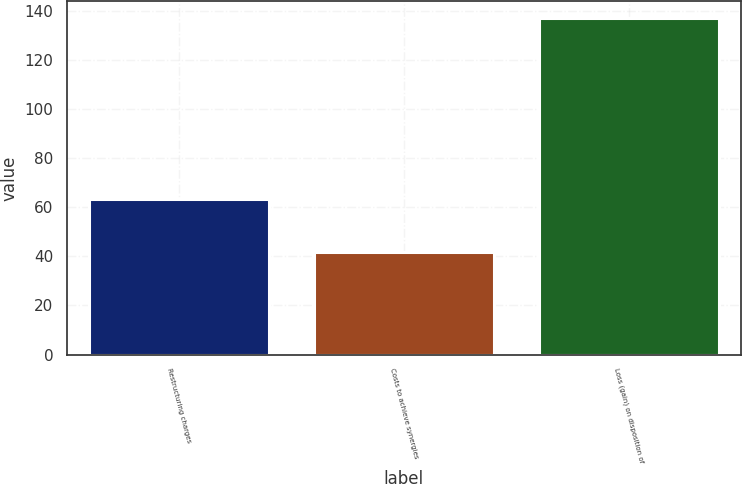Convert chart to OTSL. <chart><loc_0><loc_0><loc_500><loc_500><bar_chart><fcel>Restructuring charges<fcel>Costs to achieve synergies<fcel>Loss (gain) on disposition of<nl><fcel>63.2<fcel>41.8<fcel>137<nl></chart> 